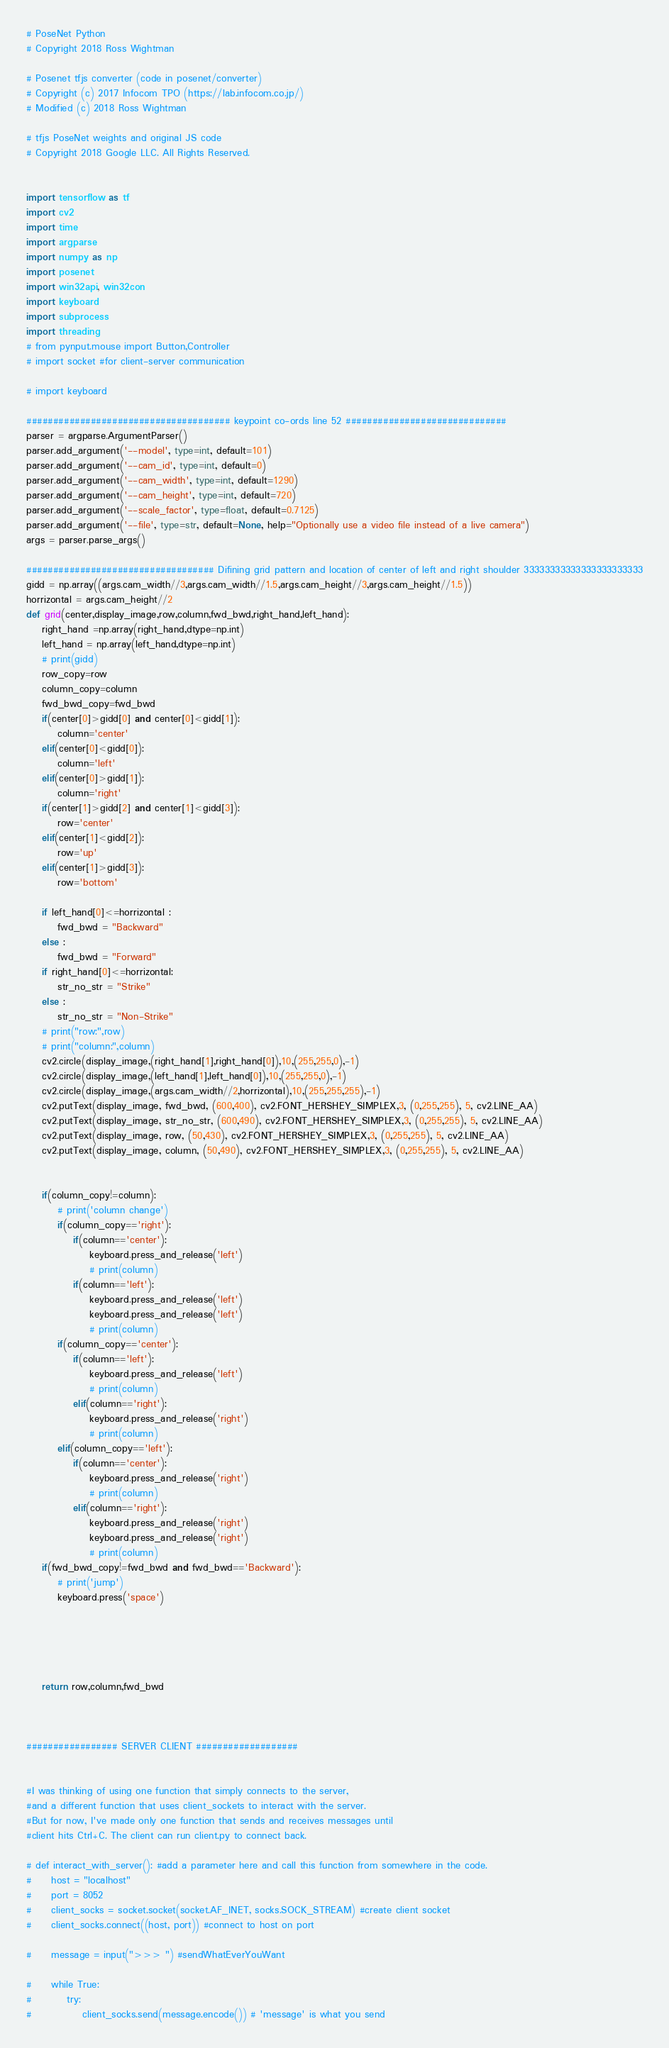Convert code to text. <code><loc_0><loc_0><loc_500><loc_500><_Python_># PoseNet Python
# Copyright 2018 Ross Wightman

# Posenet tfjs converter (code in posenet/converter)
# Copyright (c) 2017 Infocom TPO (https://lab.infocom.co.jp/)
# Modified (c) 2018 Ross Wightman

# tfjs PoseNet weights and original JS code
# Copyright 2018 Google LLC. All Rights Reserved.


import tensorflow as tf
import cv2
import time
import argparse
import numpy as np
import posenet
import win32api, win32con
import keyboard
import subprocess
import threading
# from pynput.mouse import Button,Controller
# import socket #for client-server communication

# import keyboard

###################################### keypoint co-ords line 52 ##############################
parser = argparse.ArgumentParser()
parser.add_argument('--model', type=int, default=101)
parser.add_argument('--cam_id', type=int, default=0)
parser.add_argument('--cam_width', type=int, default=1290)
parser.add_argument('--cam_height', type=int, default=720)
parser.add_argument('--scale_factor', type=float, default=0.7125)
parser.add_argument('--file', type=str, default=None, help="Optionally use a video file instead of a live camera")
args = parser.parse_args()

################################### Difining grid pattern and location of center of left and right shoulder 33333333333333333333333
gidd = np.array((args.cam_width//3,args.cam_width//1.5,args.cam_height//3,args.cam_height//1.5))
horrizontal = args.cam_height//2
def grid(center,display_image,row,column,fwd_bwd,right_hand,left_hand):
    right_hand =np.array(right_hand,dtype=np.int)
    left_hand = np.array(left_hand,dtype=np.int)
    # print(gidd)
    row_copy=row
    column_copy=column
    fwd_bwd_copy=fwd_bwd
    if(center[0]>gidd[0] and center[0]<gidd[1]):
        column='center'
    elif(center[0]<gidd[0]):
        column='left'
    elif(center[0]>gidd[1]):
        column='right'
    if(center[1]>gidd[2] and center[1]<gidd[3]):
        row='center'
    elif(center[1]<gidd[2]):
        row='up'
    elif(center[1]>gidd[3]):
        row='bottom'
    
    if left_hand[0]<=horrizontal :
        fwd_bwd = "Backward"
    else : 
        fwd_bwd = "Forward"
    if right_hand[0]<=horrizontal:
        str_no_str = "Strike"
    else : 
        str_no_str = "Non-Strike"
    # print("row:",row)
    # print("column:",column)
    cv2.circle(display_image,(right_hand[1],right_hand[0]),10,(255,255,0),-1)
    cv2.circle(display_image,(left_hand[1],left_hand[0]),10,(255,255,0),-1)
    cv2.circle(display_image,(args.cam_width//2,horrizontal),10,(255,255,255),-1)
    cv2.putText(display_image, fwd_bwd, (600,400), cv2.FONT_HERSHEY_SIMPLEX,3, (0,255,255), 5, cv2.LINE_AA)
    cv2.putText(display_image, str_no_str, (600,490), cv2.FONT_HERSHEY_SIMPLEX,3, (0,255,255), 5, cv2.LINE_AA)
    cv2.putText(display_image, row, (50,430), cv2.FONT_HERSHEY_SIMPLEX,3, (0,255,255), 5, cv2.LINE_AA) 
    cv2.putText(display_image, column, (50,490), cv2.FONT_HERSHEY_SIMPLEX,3, (0,255,255), 5, cv2.LINE_AA)
    

    if(column_copy!=column):
        # print('column change')
        if(column_copy=='right'):
            if(column=='center'):
                keyboard.press_and_release('left')
                # print(column)
            if(column=='left'):
                keyboard.press_and_release('left')
                keyboard.press_and_release('left')
                # print(column)
        if(column_copy=='center'):
            if(column=='left'):
                keyboard.press_and_release('left')
                # print(column)
            elif(column=='right'):
                keyboard.press_and_release('right')
                # print(column)
        elif(column_copy=='left'):
            if(column=='center'):
                keyboard.press_and_release('right')
                # print(column)
            elif(column=='right'):
                keyboard.press_and_release('right')
                keyboard.press_and_release('right')
                # print(column)
    if(fwd_bwd_copy!=fwd_bwd and fwd_bwd=='Backward'):
        # print('jump')
        keyboard.press('space')
    
    
    

    
    return row,column,fwd_bwd



################# SERVER CLIENT ###################


#I was thinking of using one function that simply connects to the server, 
#and a different function that uses client_sockets to interact with the server.
#But for now, I've made only one function that sends and receives messages until 
#client hits Ctrl+C. The client can run client.py to connect back.

# def interact_with_server(): #add a parameter here and call this function from somewhere in the code.
#     host = "localhost"
#     port = 8052
#     client_socks = socket.socket(socket.AF_INET, socks.SOCK_STREAM) #create client socket
#     client_socks.connect((host, port)) #connect to host on port

#     message = input(">>> ") #sendWhatEverYouWant

#     while True:
#         try:
#             client_socks.send(message.encode()) # 'message' is what you send</code> 